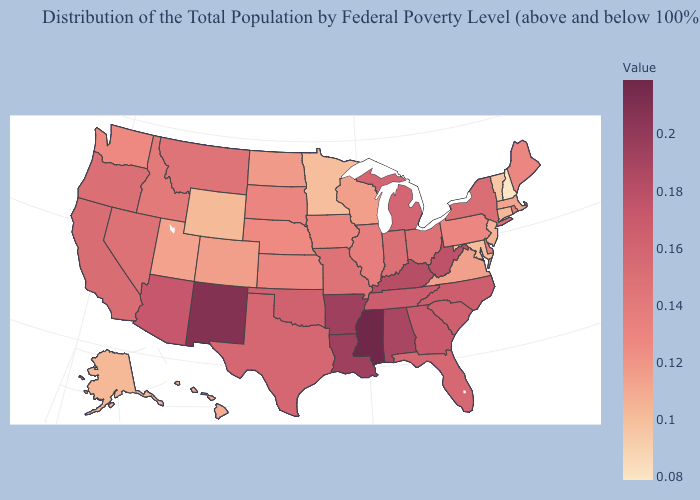Among the states that border New Hampshire , does Vermont have the highest value?
Write a very short answer. No. Does Rhode Island have the lowest value in the Northeast?
Short answer required. No. Which states have the highest value in the USA?
Concise answer only. Mississippi. Which states have the lowest value in the USA?
Be succinct. New Hampshire. Is the legend a continuous bar?
Keep it brief. Yes. Which states have the highest value in the USA?
Answer briefly. Mississippi. 